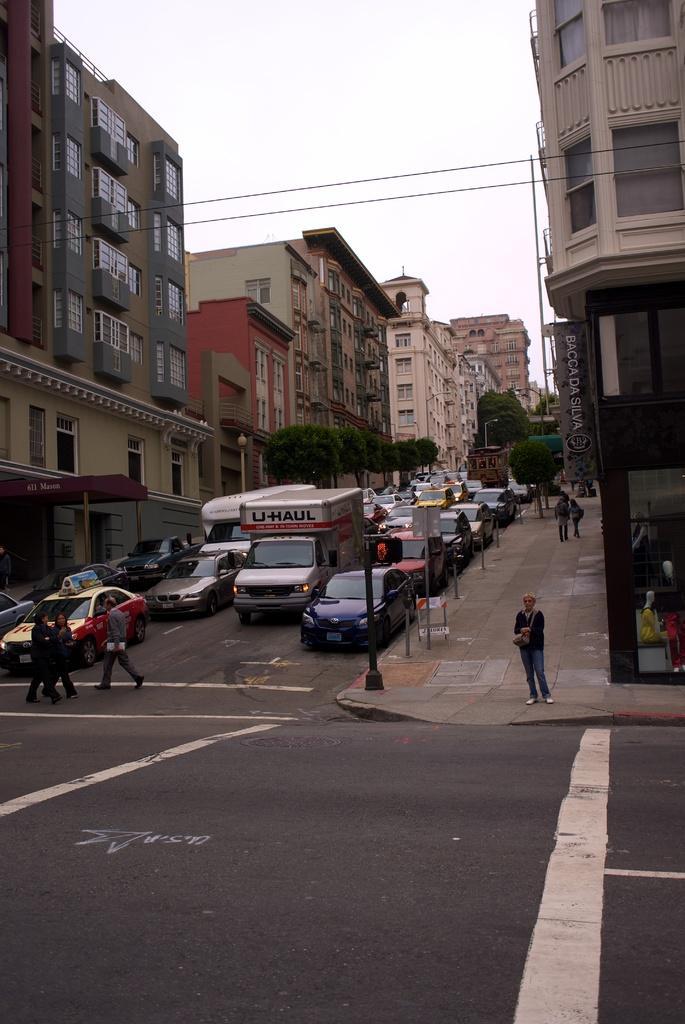In one or two sentences, can you explain what this image depicts? In this picture we can see some vehicles traveling on the road, there are three persons crossing the road, we can see a person standing here, on the right side and left side there are buildings, we can see trees here, there is a pole her, we can see the sky at the top of the picture. 